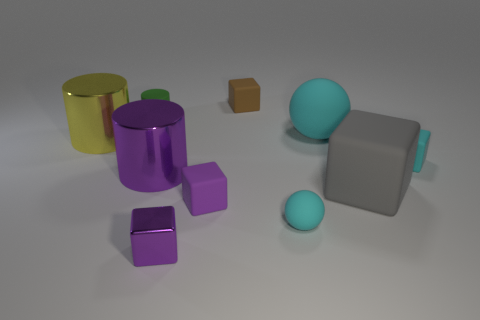Subtract 2 cubes. How many cubes are left? 3 Subtract all cyan blocks. How many blocks are left? 4 Subtract all tiny purple metal cubes. How many cubes are left? 4 Subtract all blue blocks. Subtract all red cylinders. How many blocks are left? 5 Subtract all spheres. How many objects are left? 8 Subtract all tiny matte cylinders. Subtract all metal objects. How many objects are left? 6 Add 1 tiny purple things. How many tiny purple things are left? 3 Add 4 large metal things. How many large metal things exist? 6 Subtract 0 blue balls. How many objects are left? 10 